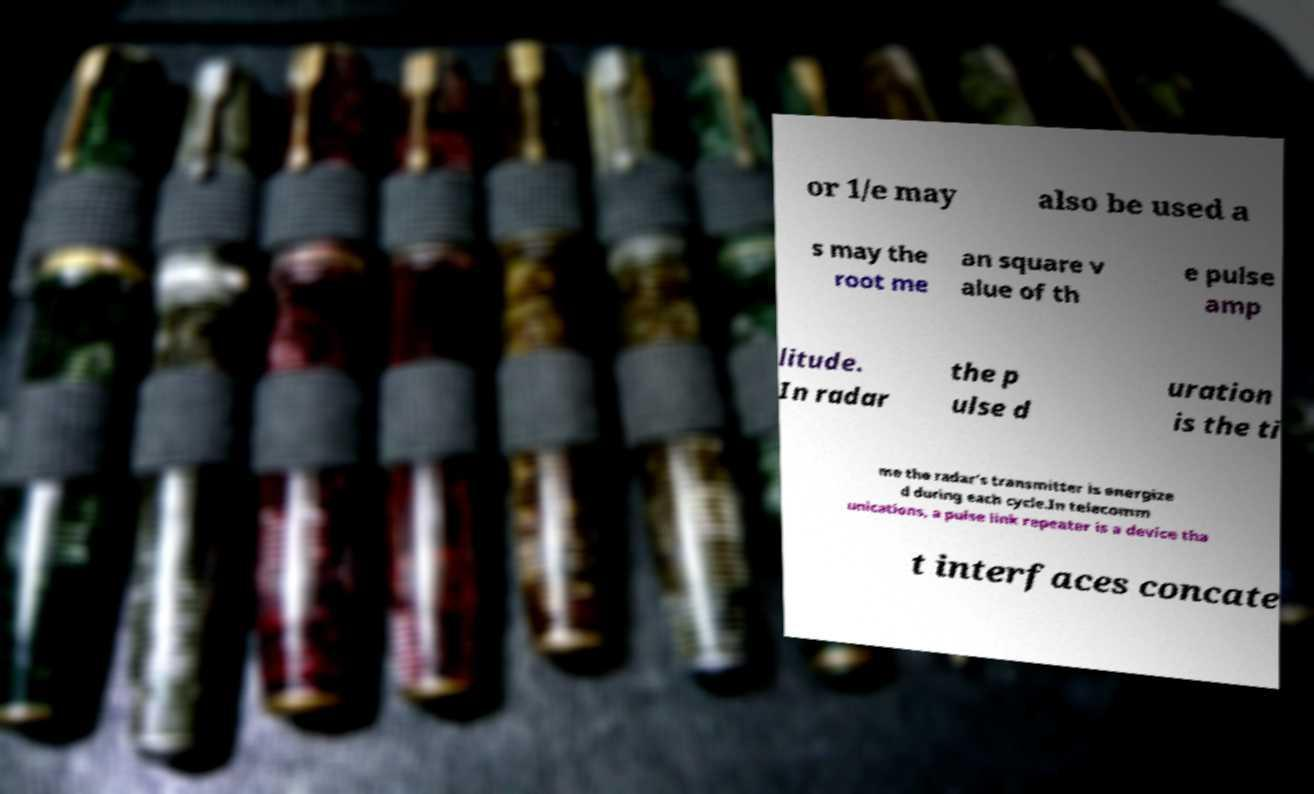Could you extract and type out the text from this image? or 1/e may also be used a s may the root me an square v alue of th e pulse amp litude. In radar the p ulse d uration is the ti me the radar's transmitter is energize d during each cycle.In telecomm unications, a pulse link repeater is a device tha t interfaces concate 